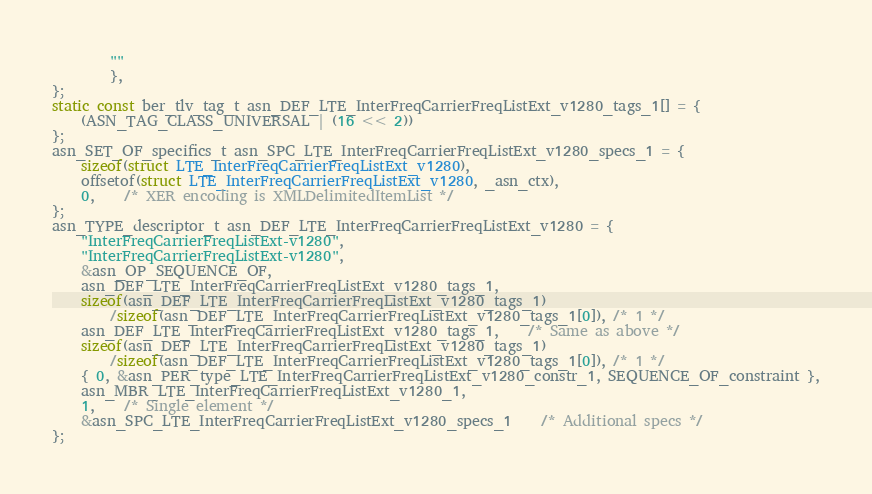<code> <loc_0><loc_0><loc_500><loc_500><_C_>		""
		},
};
static const ber_tlv_tag_t asn_DEF_LTE_InterFreqCarrierFreqListExt_v1280_tags_1[] = {
	(ASN_TAG_CLASS_UNIVERSAL | (16 << 2))
};
asn_SET_OF_specifics_t asn_SPC_LTE_InterFreqCarrierFreqListExt_v1280_specs_1 = {
	sizeof(struct LTE_InterFreqCarrierFreqListExt_v1280),
	offsetof(struct LTE_InterFreqCarrierFreqListExt_v1280, _asn_ctx),
	0,	/* XER encoding is XMLDelimitedItemList */
};
asn_TYPE_descriptor_t asn_DEF_LTE_InterFreqCarrierFreqListExt_v1280 = {
	"InterFreqCarrierFreqListExt-v1280",
	"InterFreqCarrierFreqListExt-v1280",
	&asn_OP_SEQUENCE_OF,
	asn_DEF_LTE_InterFreqCarrierFreqListExt_v1280_tags_1,
	sizeof(asn_DEF_LTE_InterFreqCarrierFreqListExt_v1280_tags_1)
		/sizeof(asn_DEF_LTE_InterFreqCarrierFreqListExt_v1280_tags_1[0]), /* 1 */
	asn_DEF_LTE_InterFreqCarrierFreqListExt_v1280_tags_1,	/* Same as above */
	sizeof(asn_DEF_LTE_InterFreqCarrierFreqListExt_v1280_tags_1)
		/sizeof(asn_DEF_LTE_InterFreqCarrierFreqListExt_v1280_tags_1[0]), /* 1 */
	{ 0, &asn_PER_type_LTE_InterFreqCarrierFreqListExt_v1280_constr_1, SEQUENCE_OF_constraint },
	asn_MBR_LTE_InterFreqCarrierFreqListExt_v1280_1,
	1,	/* Single element */
	&asn_SPC_LTE_InterFreqCarrierFreqListExt_v1280_specs_1	/* Additional specs */
};

</code> 